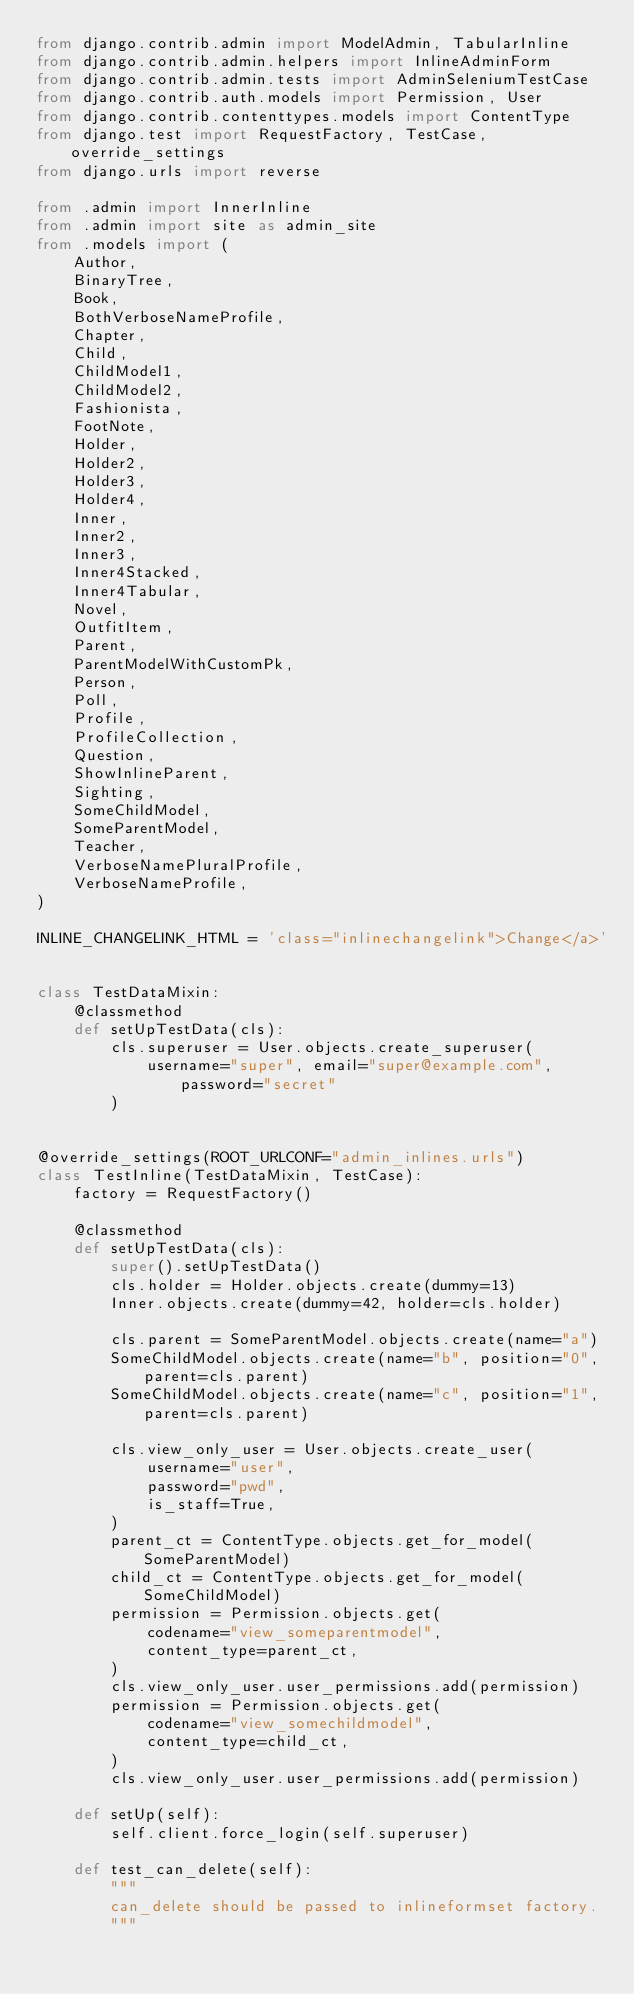Convert code to text. <code><loc_0><loc_0><loc_500><loc_500><_Python_>from django.contrib.admin import ModelAdmin, TabularInline
from django.contrib.admin.helpers import InlineAdminForm
from django.contrib.admin.tests import AdminSeleniumTestCase
from django.contrib.auth.models import Permission, User
from django.contrib.contenttypes.models import ContentType
from django.test import RequestFactory, TestCase, override_settings
from django.urls import reverse

from .admin import InnerInline
from .admin import site as admin_site
from .models import (
    Author,
    BinaryTree,
    Book,
    BothVerboseNameProfile,
    Chapter,
    Child,
    ChildModel1,
    ChildModel2,
    Fashionista,
    FootNote,
    Holder,
    Holder2,
    Holder3,
    Holder4,
    Inner,
    Inner2,
    Inner3,
    Inner4Stacked,
    Inner4Tabular,
    Novel,
    OutfitItem,
    Parent,
    ParentModelWithCustomPk,
    Person,
    Poll,
    Profile,
    ProfileCollection,
    Question,
    ShowInlineParent,
    Sighting,
    SomeChildModel,
    SomeParentModel,
    Teacher,
    VerboseNamePluralProfile,
    VerboseNameProfile,
)

INLINE_CHANGELINK_HTML = 'class="inlinechangelink">Change</a>'


class TestDataMixin:
    @classmethod
    def setUpTestData(cls):
        cls.superuser = User.objects.create_superuser(
            username="super", email="super@example.com", password="secret"
        )


@override_settings(ROOT_URLCONF="admin_inlines.urls")
class TestInline(TestDataMixin, TestCase):
    factory = RequestFactory()

    @classmethod
    def setUpTestData(cls):
        super().setUpTestData()
        cls.holder = Holder.objects.create(dummy=13)
        Inner.objects.create(dummy=42, holder=cls.holder)

        cls.parent = SomeParentModel.objects.create(name="a")
        SomeChildModel.objects.create(name="b", position="0", parent=cls.parent)
        SomeChildModel.objects.create(name="c", position="1", parent=cls.parent)

        cls.view_only_user = User.objects.create_user(
            username="user",
            password="pwd",
            is_staff=True,
        )
        parent_ct = ContentType.objects.get_for_model(SomeParentModel)
        child_ct = ContentType.objects.get_for_model(SomeChildModel)
        permission = Permission.objects.get(
            codename="view_someparentmodel",
            content_type=parent_ct,
        )
        cls.view_only_user.user_permissions.add(permission)
        permission = Permission.objects.get(
            codename="view_somechildmodel",
            content_type=child_ct,
        )
        cls.view_only_user.user_permissions.add(permission)

    def setUp(self):
        self.client.force_login(self.superuser)

    def test_can_delete(self):
        """
        can_delete should be passed to inlineformset factory.
        """</code> 